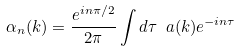Convert formula to latex. <formula><loc_0><loc_0><loc_500><loc_500>\alpha _ { n } ( k ) = \frac { e ^ { i n \pi / 2 } } { 2 \pi } \int d { \tau } \ a ( { k } ) e ^ { - i n \tau }</formula> 